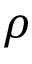Convert formula to latex. <formula><loc_0><loc_0><loc_500><loc_500>\rho</formula> 